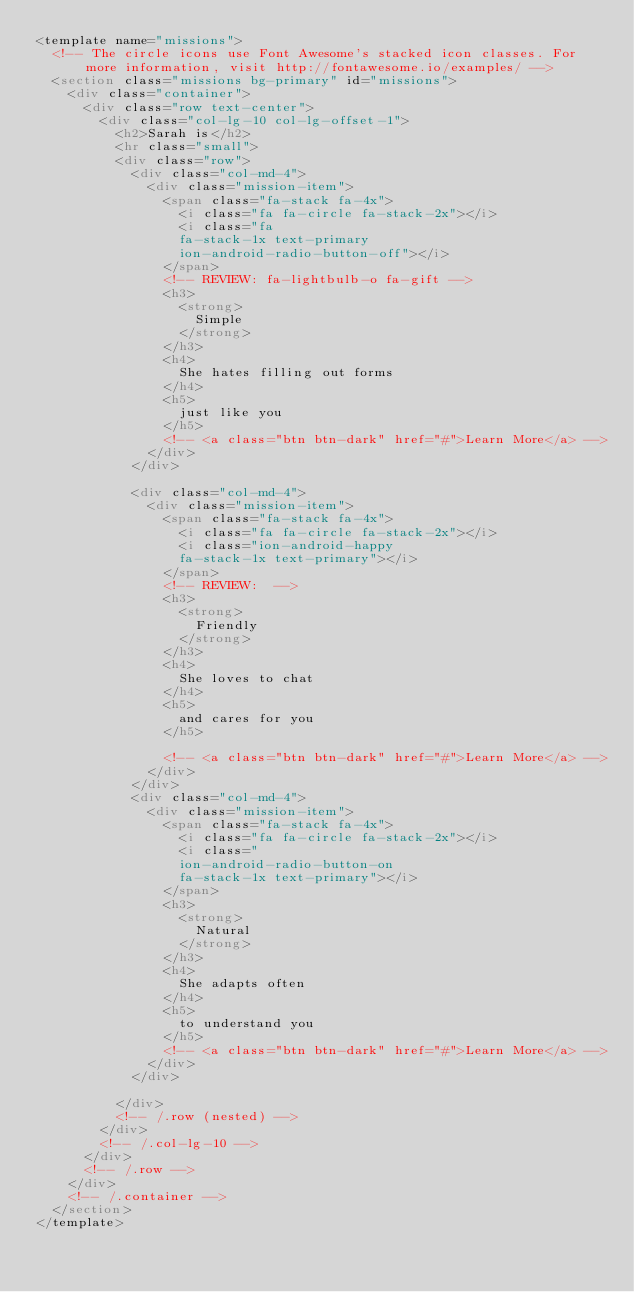Convert code to text. <code><loc_0><loc_0><loc_500><loc_500><_HTML_><template name="missions">
  <!-- The circle icons use Font Awesome's stacked icon classes. For more information, visit http://fontawesome.io/examples/ -->
  <section class="missions bg-primary" id="missions">
    <div class="container">
      <div class="row text-center">
        <div class="col-lg-10 col-lg-offset-1">
          <h2>Sarah is</h2>
          <hr class="small">
          <div class="row">
            <div class="col-md-4">
              <div class="mission-item">
                <span class="fa-stack fa-4x">
                  <i class="fa fa-circle fa-stack-2x"></i>
                  <i class="fa
                  fa-stack-1x text-primary
                  ion-android-radio-button-off"></i>
                </span>
                <!-- REVIEW: fa-lightbulb-o fa-gift -->
                <h3>
                  <strong>
                    Simple
                  </strong>
                </h3>
                <h4>
                  She hates filling out forms
                </h4>
                <h5>
                  just like you
                </h5>
                <!-- <a class="btn btn-dark" href="#">Learn More</a> -->
              </div>
            </div>

            <div class="col-md-4">
              <div class="mission-item">
                <span class="fa-stack fa-4x">
                  <i class="fa fa-circle fa-stack-2x"></i>
                  <i class="ion-android-happy
                  fa-stack-1x text-primary"></i>
                </span>
                <!-- REVIEW:  -->
                <h3>
                  <strong>
                    Friendly
                  </strong>
                </h3>
                <h4>
                  She loves to chat
                </h4>
                <h5>
                  and cares for you
                </h5>

                <!-- <a class="btn btn-dark" href="#">Learn More</a> -->
              </div>
            </div>
            <div class="col-md-4">
              <div class="mission-item">
                <span class="fa-stack fa-4x">
                  <i class="fa fa-circle fa-stack-2x"></i>
                  <i class="
                  ion-android-radio-button-on
                  fa-stack-1x text-primary"></i>
                </span>
                <h3>
                  <strong>
                    Natural
                  </strong>
                </h3>
                <h4>
                  She adapts often
                </h4>
                <h5>
                  to understand you
                </h5>
                <!-- <a class="btn btn-dark" href="#">Learn More</a> -->
              </div>
            </div>

          </div>
          <!-- /.row (nested) -->
        </div>
        <!-- /.col-lg-10 -->
      </div>
      <!-- /.row -->
    </div>
    <!-- /.container -->
  </section>
</template>
</code> 